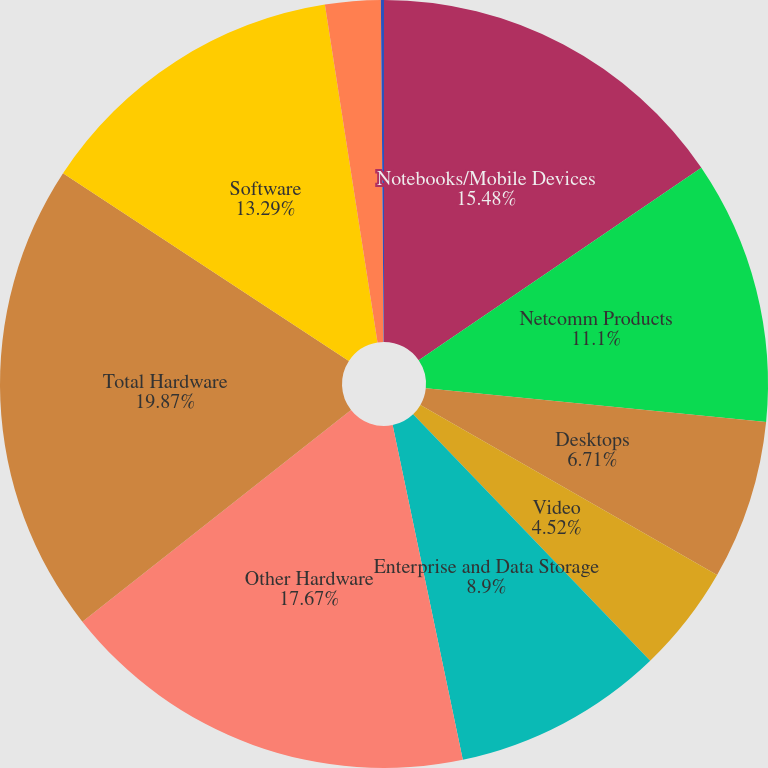Convert chart to OTSL. <chart><loc_0><loc_0><loc_500><loc_500><pie_chart><fcel>Notebooks/Mobile Devices<fcel>Netcomm Products<fcel>Desktops<fcel>Video<fcel>Enterprise and Data Storage<fcel>Other Hardware<fcel>Total Hardware<fcel>Software<fcel>Services (2)<fcel>Other (3)<nl><fcel>15.48%<fcel>11.1%<fcel>6.71%<fcel>4.52%<fcel>8.9%<fcel>17.67%<fcel>19.87%<fcel>13.29%<fcel>2.33%<fcel>0.13%<nl></chart> 